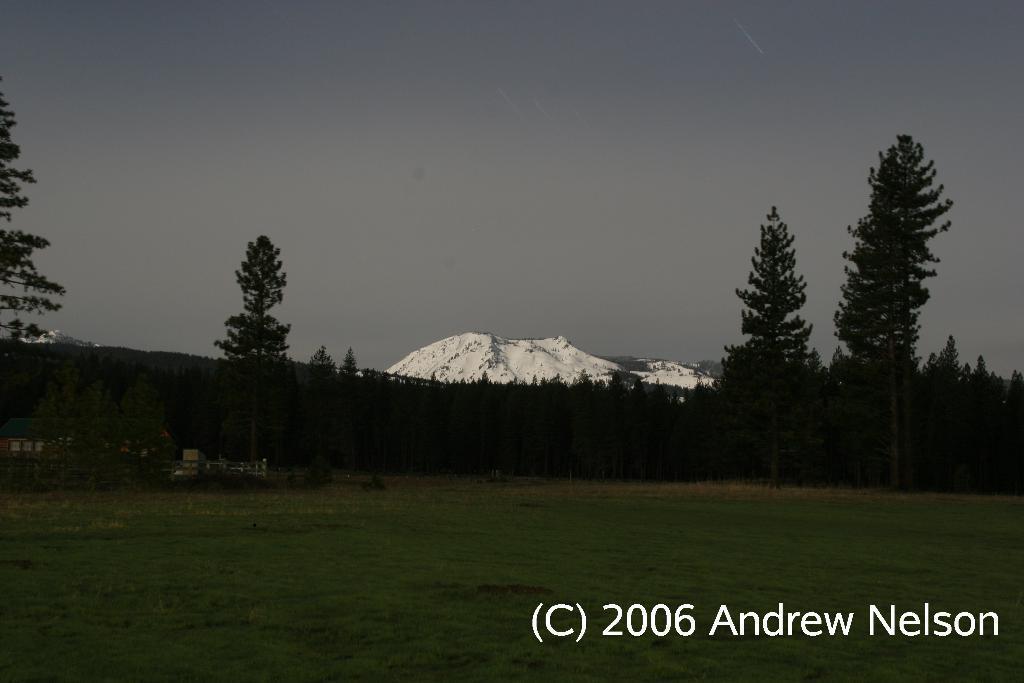How would you summarize this image in a sentence or two? In this image we can see a group of trees, grass, fence, the ice hills and the sky which looks cloudy. On the bottom of the image we can see some text. 